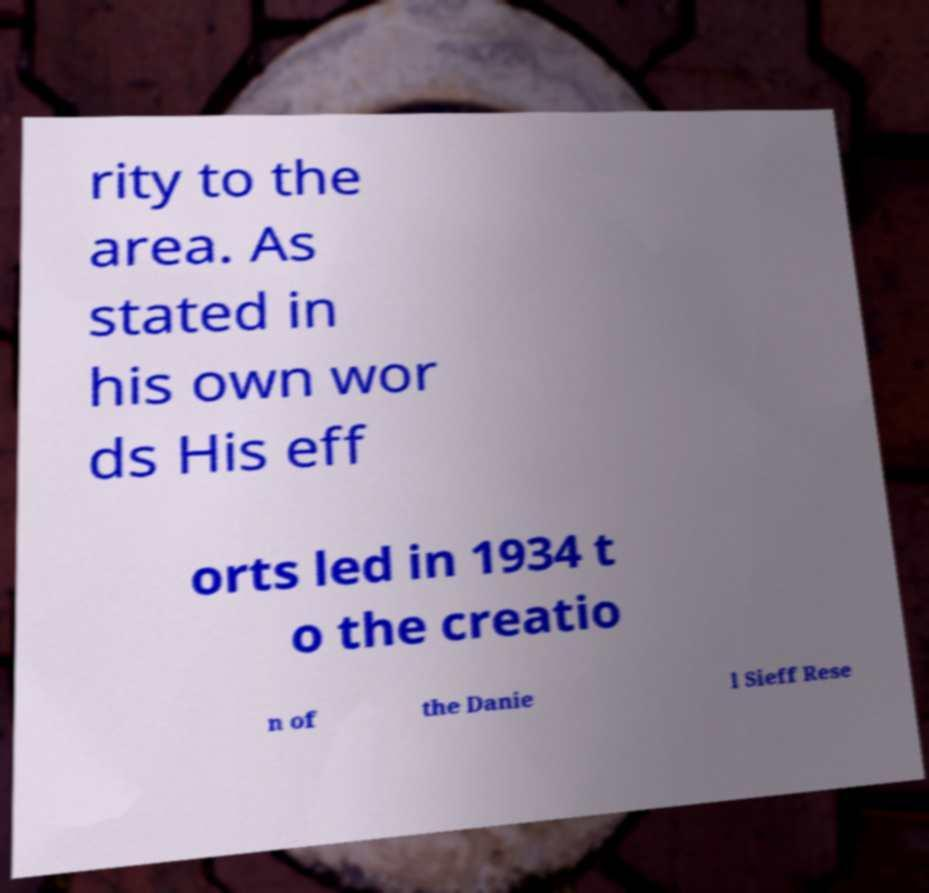Could you extract and type out the text from this image? rity to the area. As stated in his own wor ds His eff orts led in 1934 t o the creatio n of the Danie l Sieff Rese 